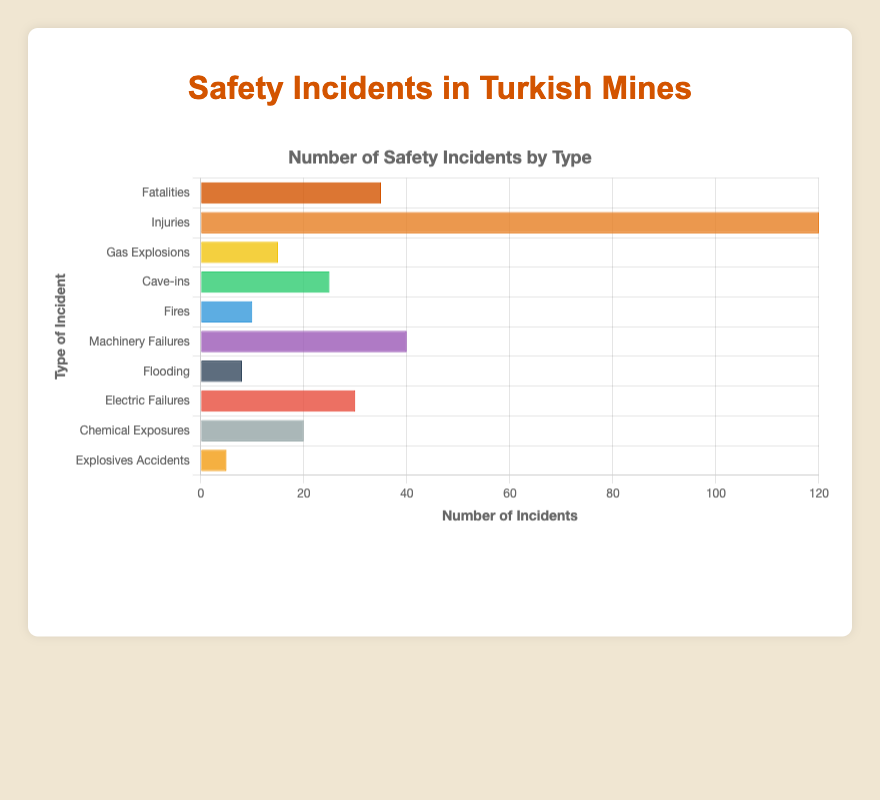Which type of safety incident has the highest number of occurrences? By looking at the lengths of the bars in the horizontal bar chart, "Injuries" has the longest bar indicating it has the highest number of occurrences.
Answer: Injuries What is the total number of safety incidents reported? Add the number of incidents for all types: 35 (Fatalities) + 120 (Injuries) + 15 (Gas Explosions) + 25 (Cave-ins) + 10 (Fires) + 40 (Machinery Failures) + 8 (Flooding) + 30 (Electric Failures) + 20 (Chemical Exposures) + 5 (Explosives Accidents) = 308
Answer: 308 Which type of incident occurs more frequently, gas explosions or cave-ins? Compare the lengths of the bars representing "Gas Explosions" and "Cave-ins". "Cave-ins" has a longer bar indicating it occurs more frequently.
Answer: Cave-ins How does the number of fatalities compare to machinery failures? The length of the bar for "Machinery Failures" is longer than for "Fatalities," indicating machinery failures occur more frequently.
Answer: Machinery Failures What is the combined number of incidents for gas explosions, cave-ins, and fires? Add the number of incidents for "Gas Explosions" (15), "Cave-ins" (25), and "Fires" (10). The sum is 15 + 25 + 10 = 50
Answer: 50 Which type of incident, besides injuries, has the second highest number of occurrences? Excluding "Injuries," look for the bar with the second longest length. "Machinery Failures" has the second longest bar.
Answer: Machinery Failures What is the percentage of fatalities out of the total safety incidents? First, find the total number of incidents (308), then calculate the percentage: (35 / 308) * 100 ≈ 11.36%
Answer: ~11.36% How many more incidents are caused by electric failures compared to fires? Subtract the number of fires (10) from electric failures (30): 30 - 10 = 20
Answer: 20 Which visual attribute helps you identify the most frequently occurring safety incident? The length of the bar represents the number of incidents, with the longest bar indicating the most frequent incident.
Answer: Length of the bar 